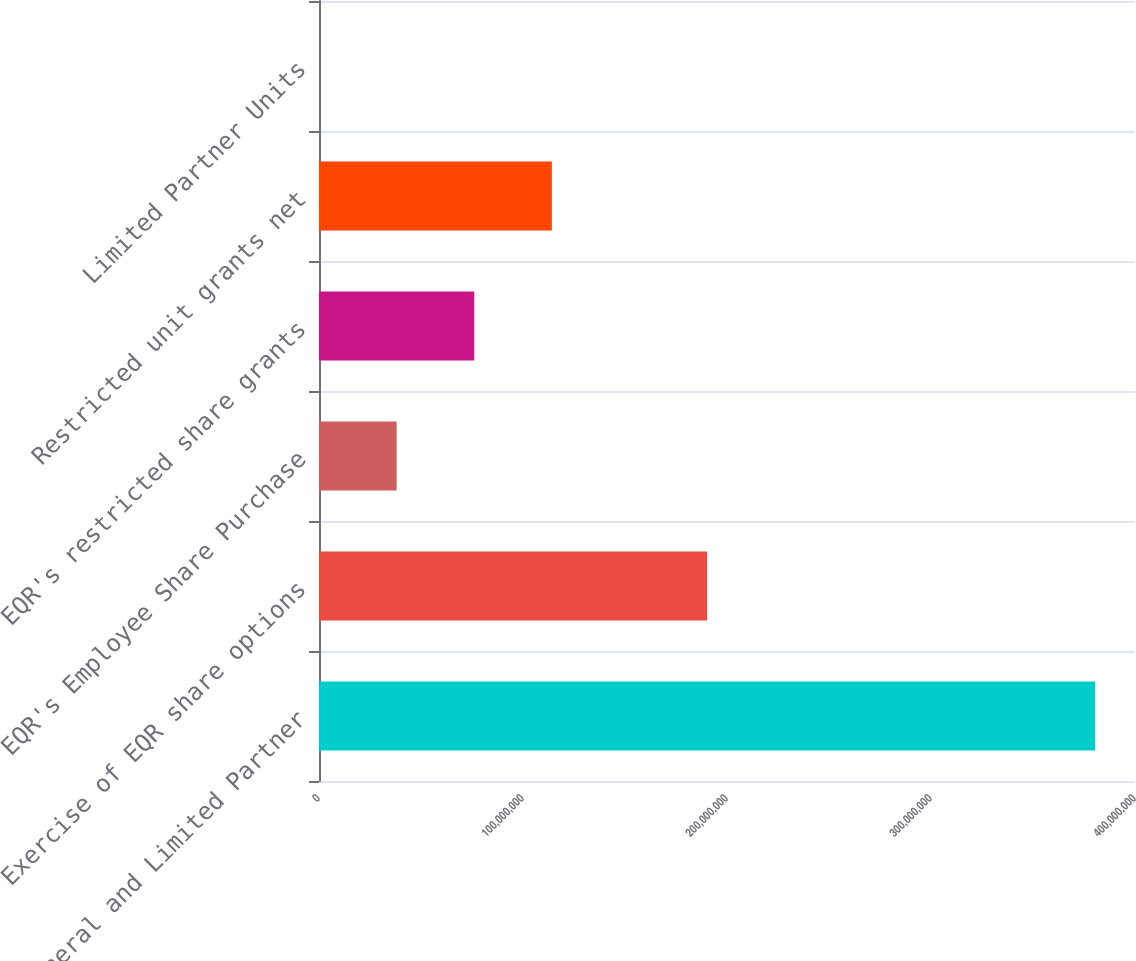Convert chart. <chart><loc_0><loc_0><loc_500><loc_500><bar_chart><fcel>General and Limited Partner<fcel>Exercise of EQR share options<fcel>EQR's Employee Share Purchase<fcel>EQR's restricted share grants<fcel>Restricted unit grants net<fcel>Limited Partner Units<nl><fcel>3.80497e+08<fcel>1.90249e+08<fcel>3.80497e+07<fcel>7.60994e+07<fcel>1.14149e+08<fcel>3.6<nl></chart> 